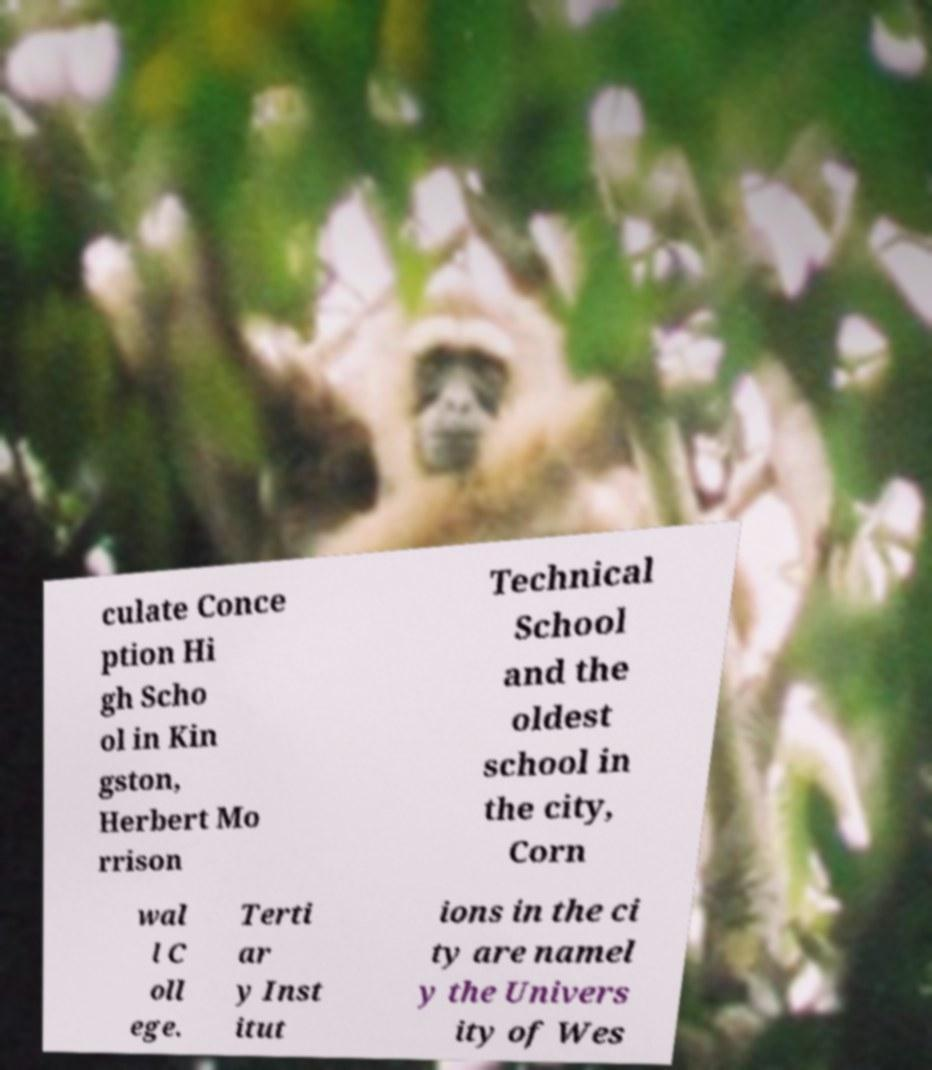Please identify and transcribe the text found in this image. culate Conce ption Hi gh Scho ol in Kin gston, Herbert Mo rrison Technical School and the oldest school in the city, Corn wal l C oll ege. Terti ar y Inst itut ions in the ci ty are namel y the Univers ity of Wes 